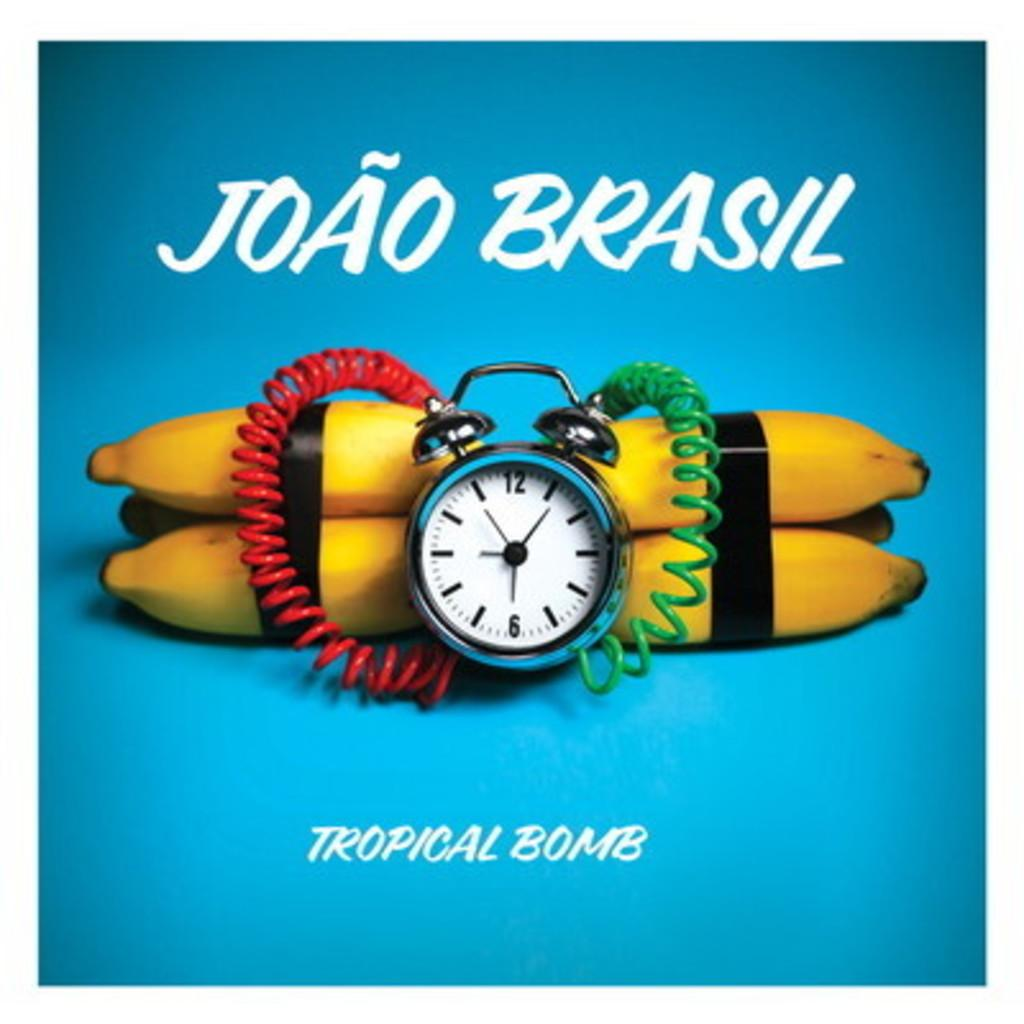<image>
Describe the image concisely. A clump of bananas taped together with wires attached to an alarm clock with the caption "tropical bomb." 